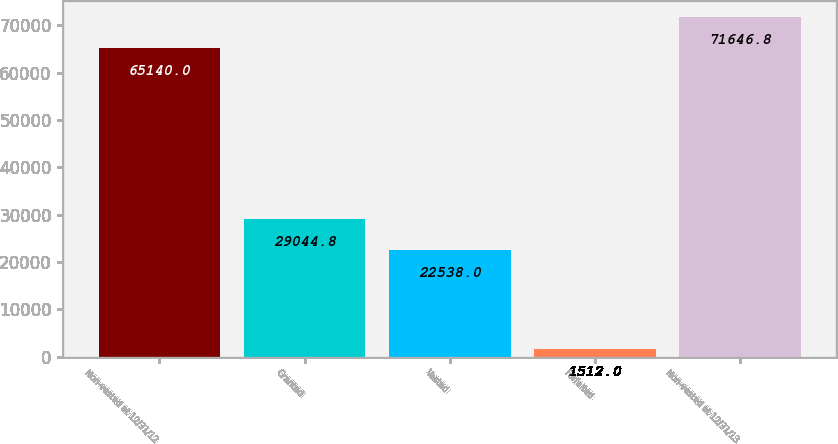Convert chart. <chart><loc_0><loc_0><loc_500><loc_500><bar_chart><fcel>Non-vested at 12/31/12<fcel>Granted<fcel>Vested<fcel>Forfeited<fcel>Non-vested at 12/31/13<nl><fcel>65140<fcel>29044.8<fcel>22538<fcel>1512<fcel>71646.8<nl></chart> 